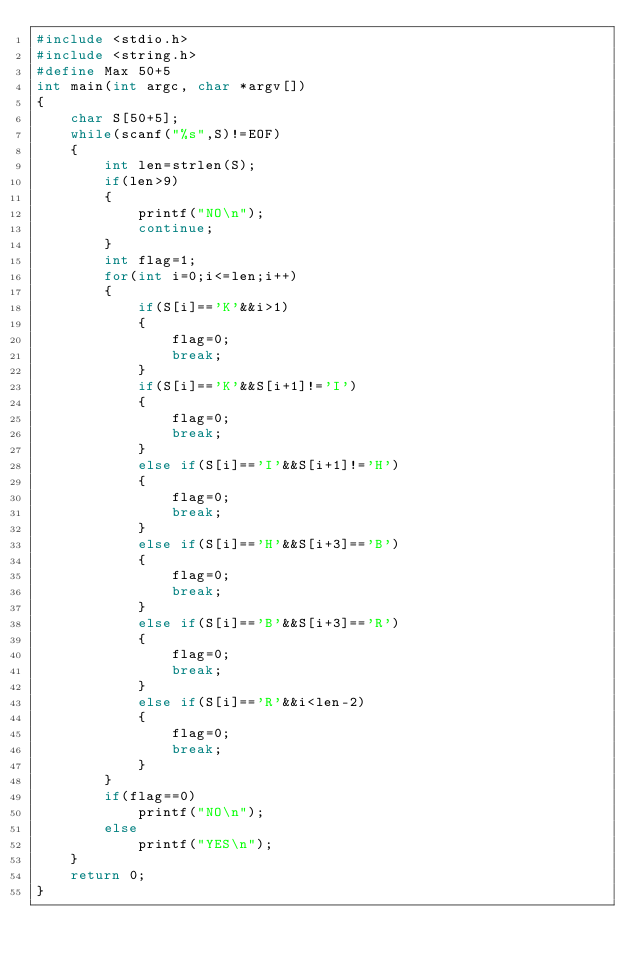Convert code to text. <code><loc_0><loc_0><loc_500><loc_500><_C_>#include <stdio.h>
#include <string.h>
#define Max 50+5
int main(int argc, char *argv[])
{
	char S[50+5];
	while(scanf("%s",S)!=EOF)
	{
		int len=strlen(S);
		if(len>9)
		{
			printf("NO\n");
			continue;
		}
		int flag=1;
		for(int i=0;i<=len;i++)
		{
			if(S[i]=='K'&&i>1)
			{
				flag=0;
				break;
			}
			if(S[i]=='K'&&S[i+1]!='I')
			{
				flag=0;
				break;
			}
			else if(S[i]=='I'&&S[i+1]!='H')
			{
				flag=0;
				break;
			}
			else if(S[i]=='H'&&S[i+3]=='B')
			{
				flag=0;
				break;
			}
			else if(S[i]=='B'&&S[i+3]=='R')
			{
				flag=0;
				break;
			}
			else if(S[i]=='R'&&i<len-2)
			{
				flag=0;
				break;
			}
		}
		if(flag==0)
			printf("NO\n");
		else
			printf("YES\n");		
	}
	return 0;
}
</code> 